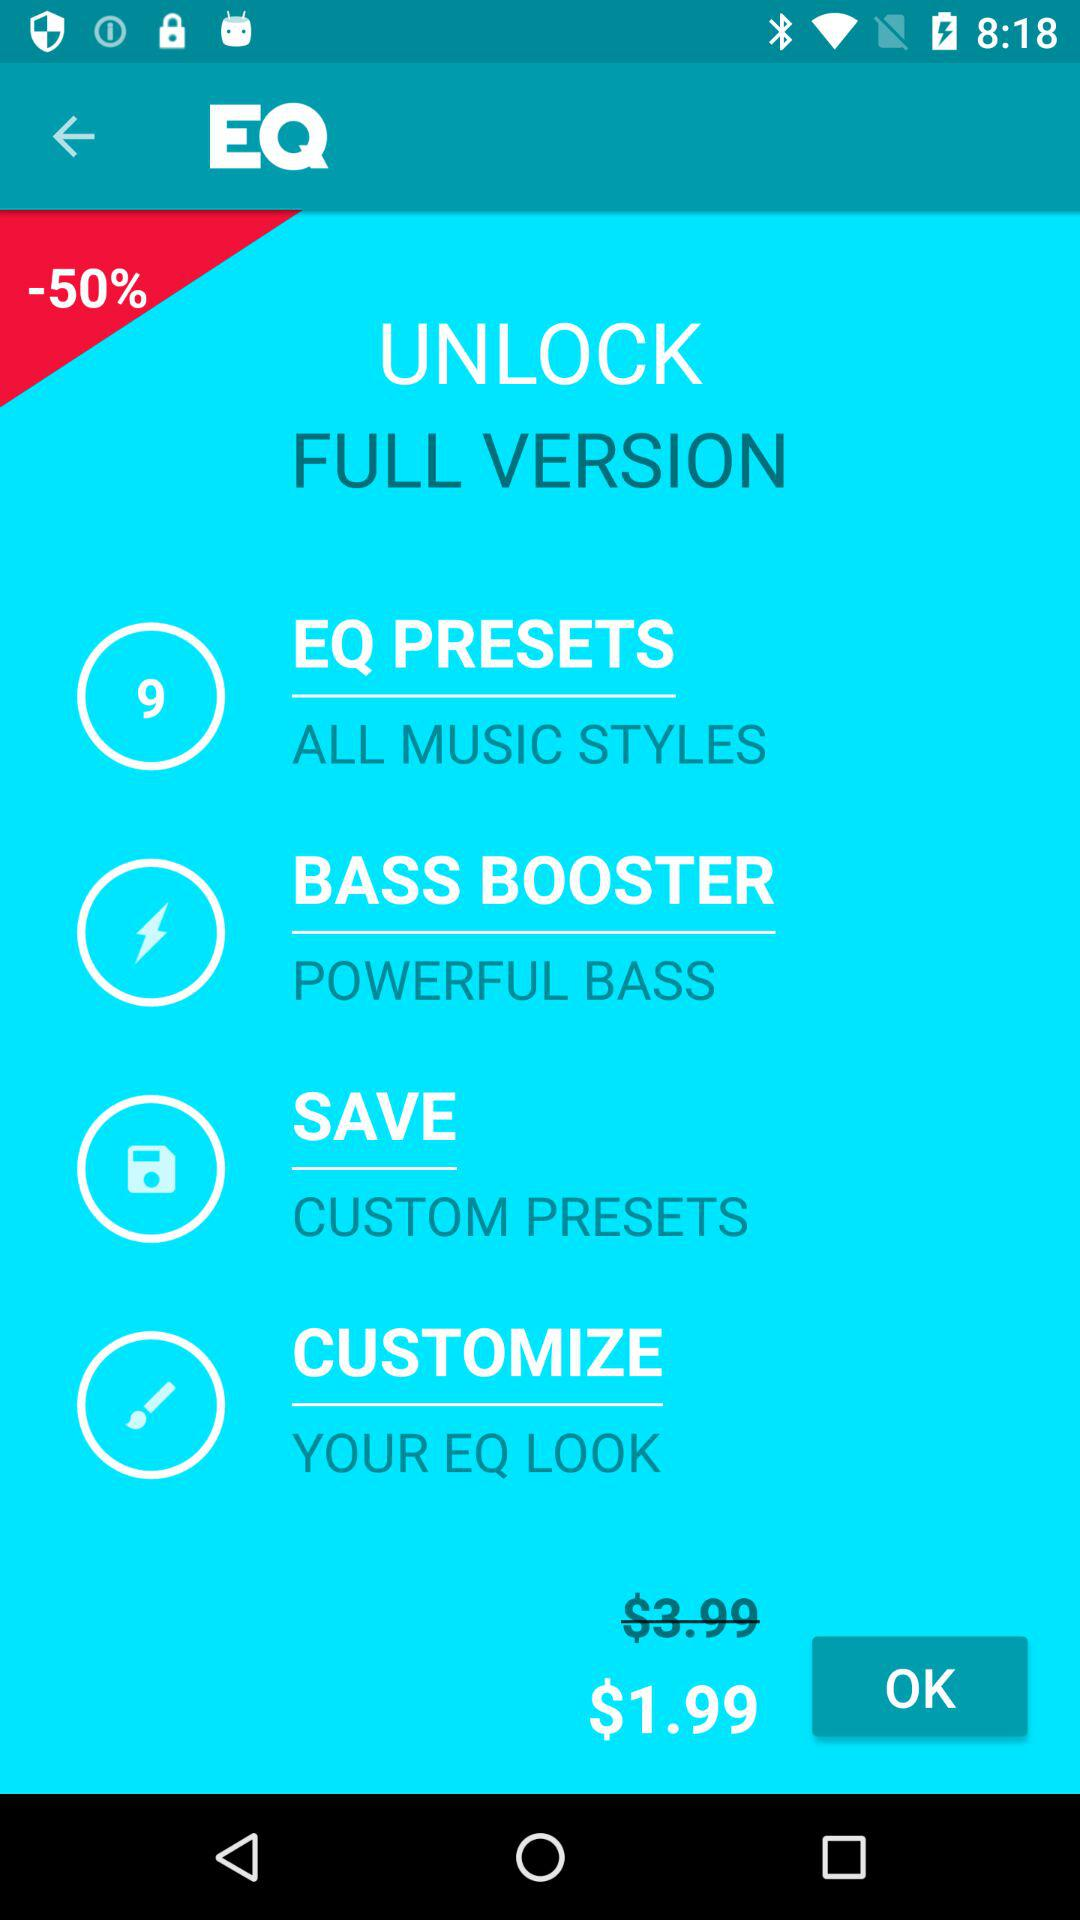Which type of currency is used for a price? The type of currency used for a price is $. 